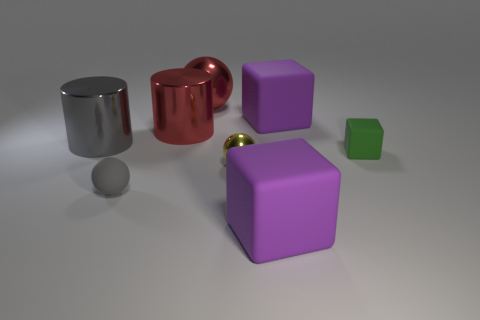Is there any other thing that has the same shape as the yellow metal thing?
Provide a succinct answer. Yes. Are the ball that is on the right side of the big red ball and the red sphere made of the same material?
Keep it short and to the point. Yes. What is the material of the green block that is the same size as the gray rubber thing?
Your response must be concise. Rubber. What number of other things are there of the same material as the small yellow object
Give a very brief answer. 3. Is the size of the gray metal object the same as the gray rubber object in front of the yellow metal ball?
Ensure brevity in your answer.  No. Is the number of large purple objects behind the small gray rubber object less than the number of small blocks that are to the right of the tiny block?
Keep it short and to the point. No. There is a metal object in front of the small green rubber object; what is its size?
Make the answer very short. Small. Is the green matte thing the same size as the yellow metal sphere?
Offer a terse response. Yes. How many purple rubber things are both behind the big gray metallic cylinder and in front of the red metallic cylinder?
Your answer should be very brief. 0. How many brown objects are either tiny objects or tiny cubes?
Provide a short and direct response. 0. 